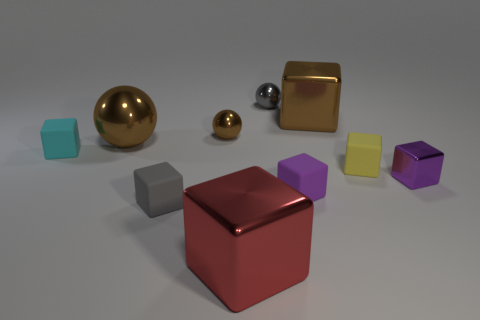What number of brown shiny objects are there?
Your answer should be compact. 3. What shape is the yellow matte thing?
Your answer should be compact. Cube. What number of gray things have the same size as the purple rubber cube?
Your answer should be compact. 2. Is the shape of the gray matte object the same as the tiny cyan matte thing?
Your answer should be very brief. Yes. What is the color of the large block behind the big object that is in front of the purple rubber block?
Give a very brief answer. Brown. There is a shiny cube that is in front of the brown shiny block and behind the large red shiny object; what size is it?
Offer a terse response. Small. Is there anything else of the same color as the big ball?
Give a very brief answer. Yes. There is a gray thing that is made of the same material as the large red block; what is its shape?
Ensure brevity in your answer.  Sphere. Is the shape of the purple metal object the same as the tiny gray thing that is behind the cyan object?
Offer a very short reply. No. What material is the big cube in front of the matte object that is behind the yellow object?
Provide a short and direct response. Metal. 